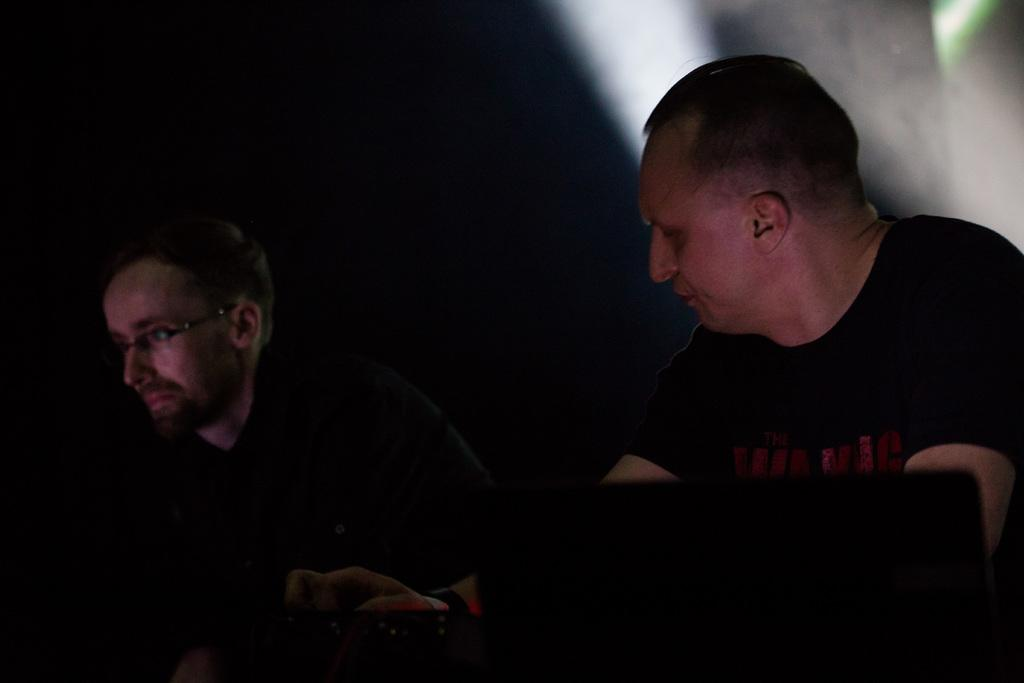What is the appearance of the man in the image? There is a man wearing glasses in the image. Can you describe the clothing of the second man in the image? There is another man wearing a black t-shirt in the image. What can be said about the background of the image? The background of the image is not clear. What type of toys can be seen on the seat in the image? There is no seat or toys present in the image. 